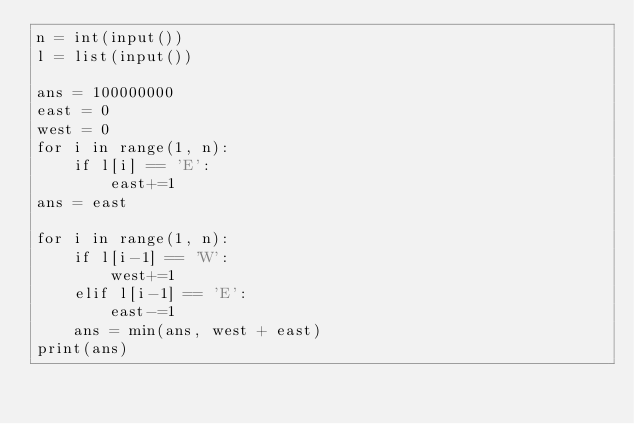<code> <loc_0><loc_0><loc_500><loc_500><_Python_>n = int(input())
l = list(input())

ans = 100000000
east = 0
west = 0
for i in range(1, n):
    if l[i] == 'E':
        east+=1
ans = east

for i in range(1, n):
    if l[i-1] == 'W':
        west+=1
    elif l[i-1] == 'E':
        east-=1
    ans = min(ans, west + east)
print(ans)
</code> 